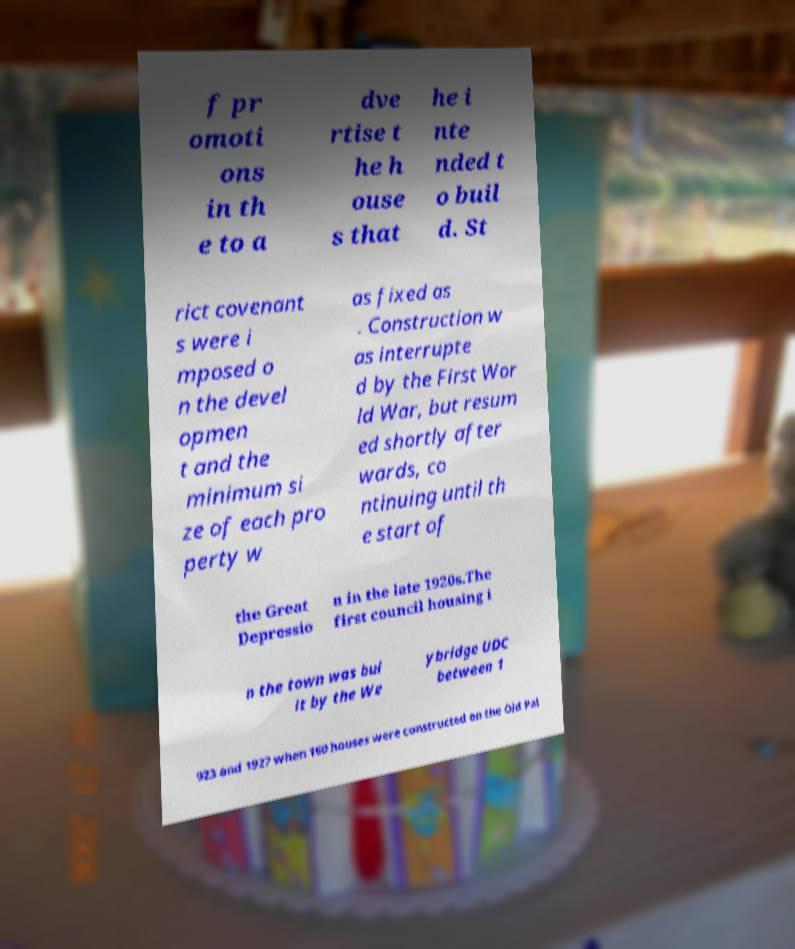What messages or text are displayed in this image? I need them in a readable, typed format. f pr omoti ons in th e to a dve rtise t he h ouse s that he i nte nded t o buil d. St rict covenant s were i mposed o n the devel opmen t and the minimum si ze of each pro perty w as fixed as . Construction w as interrupte d by the First Wor ld War, but resum ed shortly after wards, co ntinuing until th e start of the Great Depressio n in the late 1920s.The first council housing i n the town was bui lt by the We ybridge UDC between 1 923 and 1927 when 160 houses were constructed on the Old Pal 